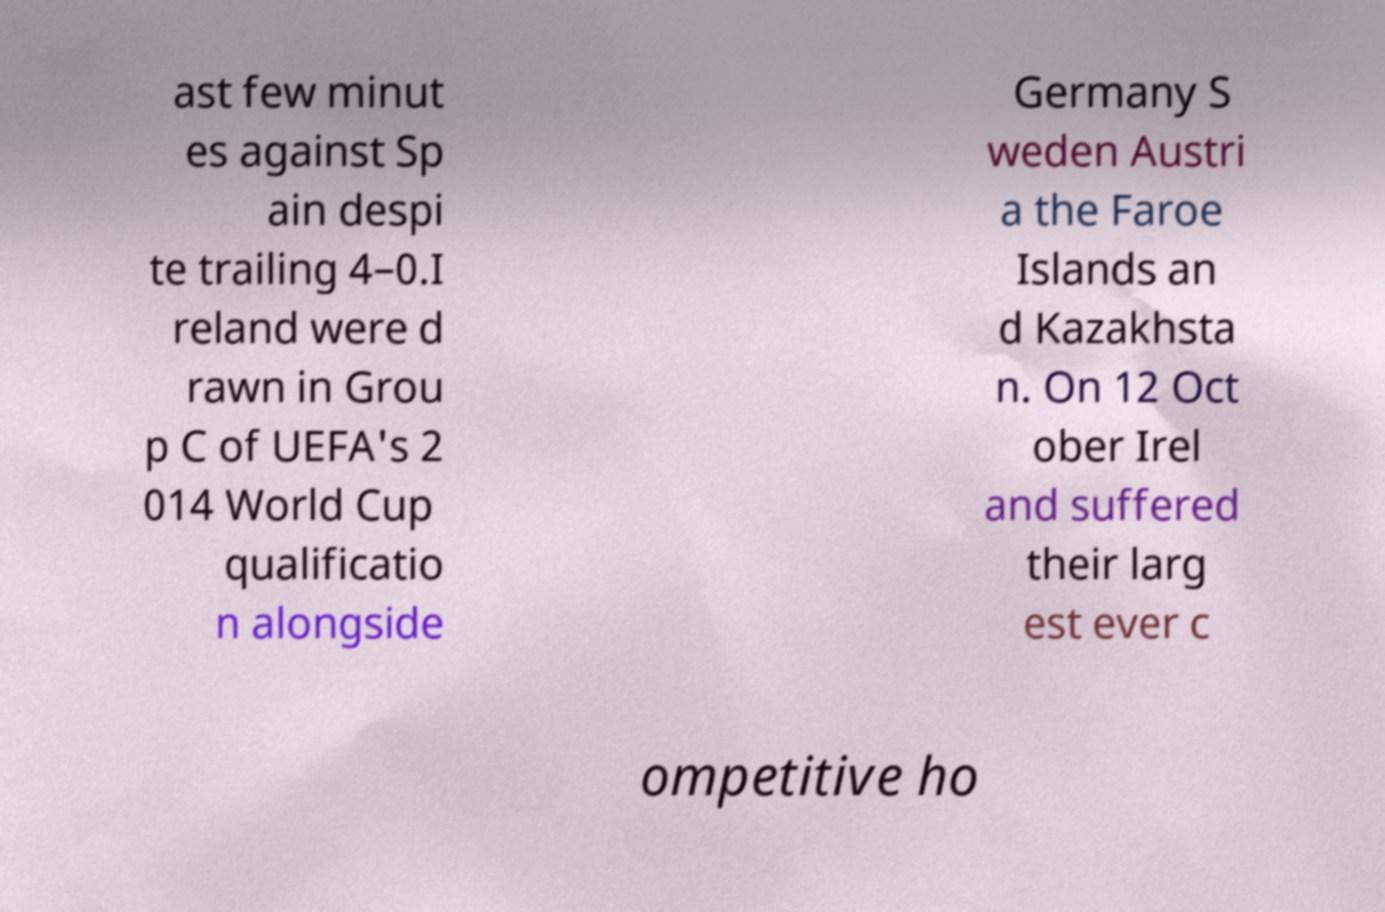Please identify and transcribe the text found in this image. ast few minut es against Sp ain despi te trailing 4–0.I reland were d rawn in Grou p C of UEFA's 2 014 World Cup qualificatio n alongside Germany S weden Austri a the Faroe Islands an d Kazakhsta n. On 12 Oct ober Irel and suffered their larg est ever c ompetitive ho 